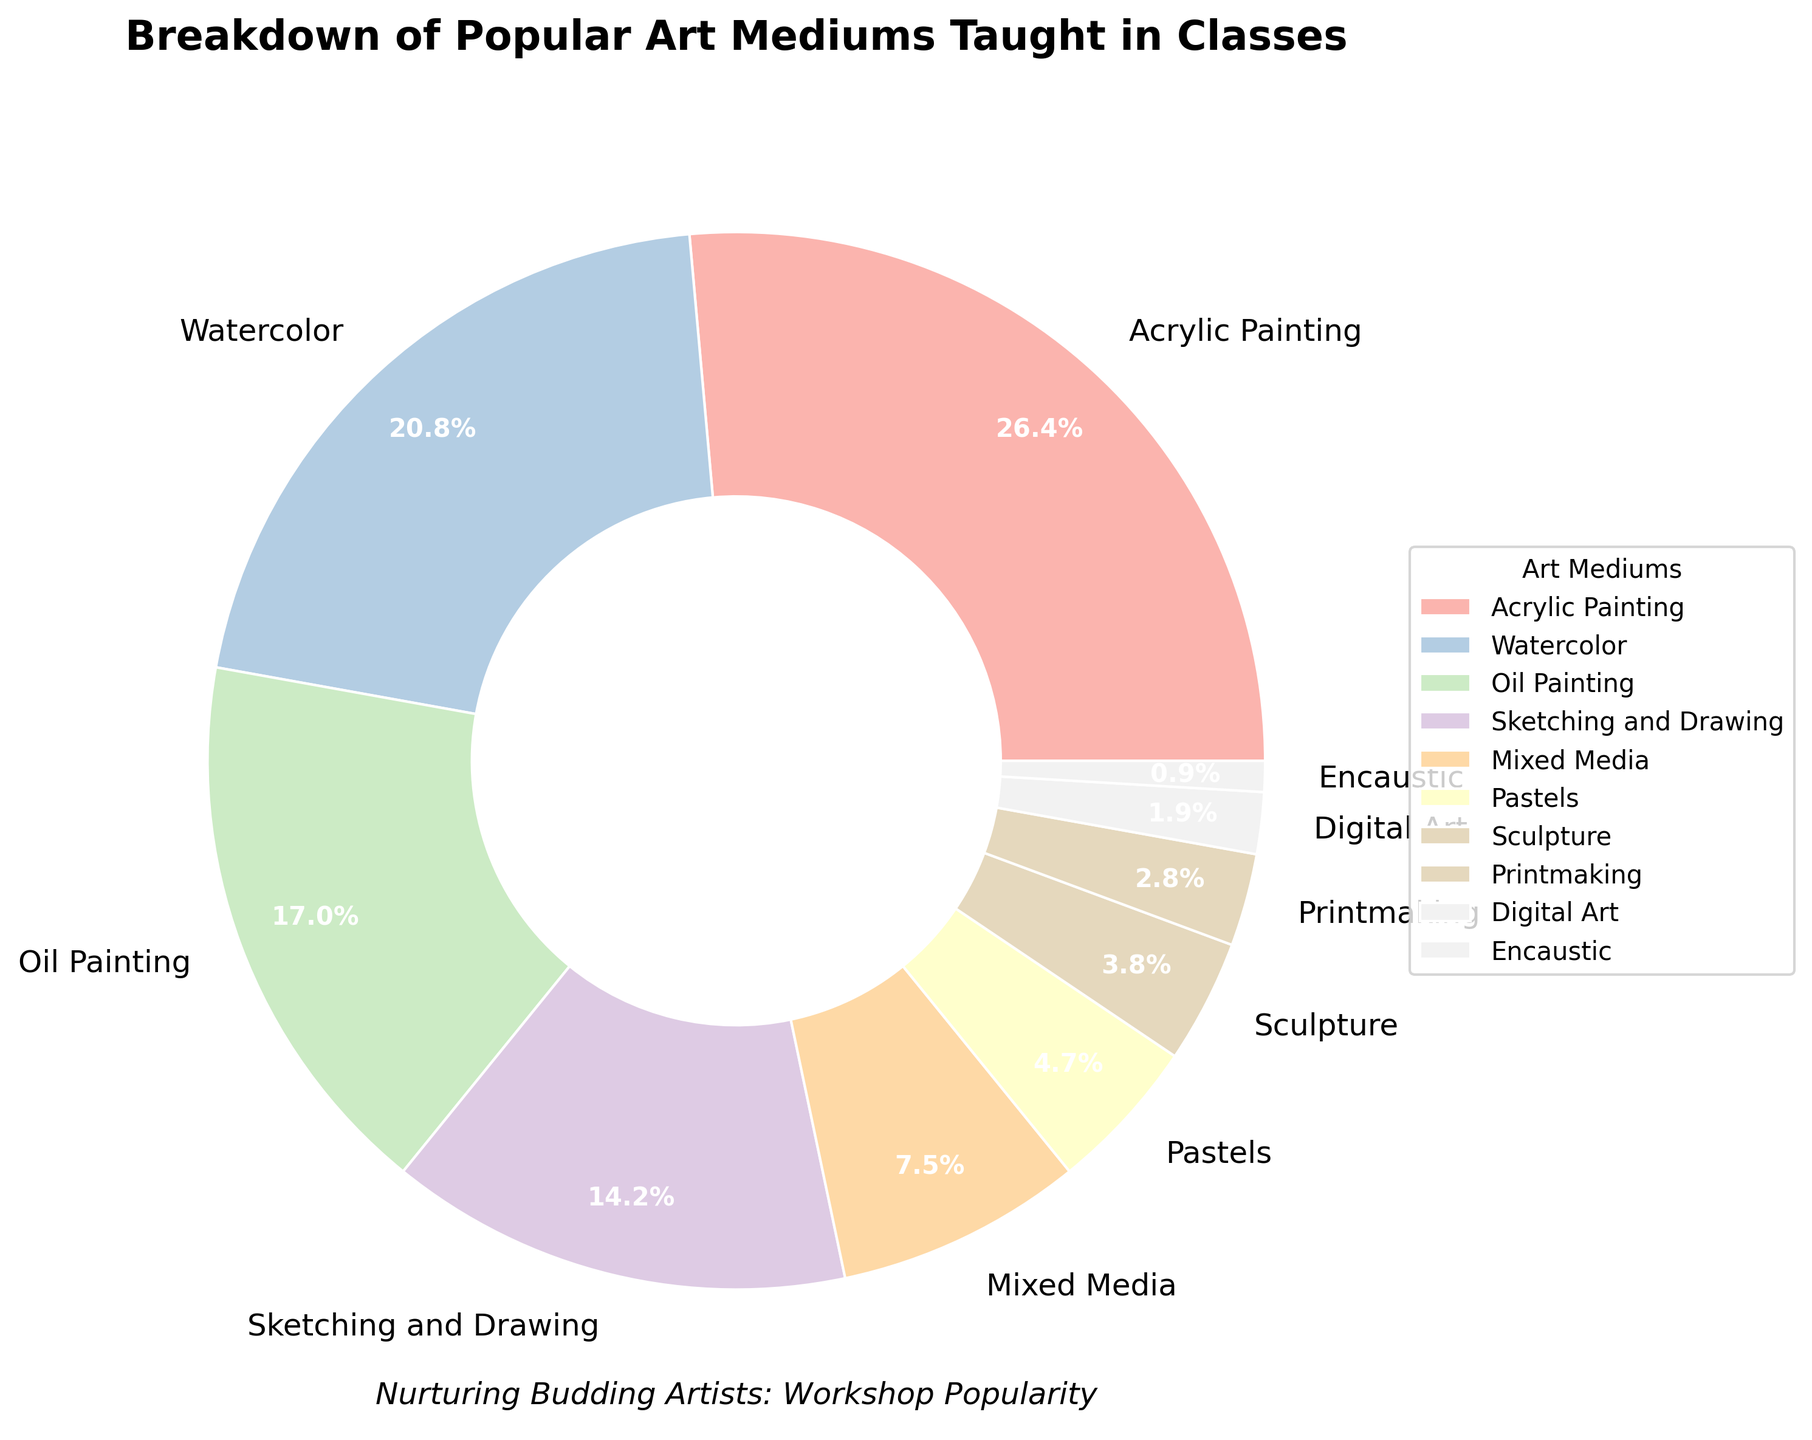What is the most popular art medium taught in classes? The slice with the largest percentage indicates the most popular art medium. According to the figure, Acrylic Painting occupies the largest section (28%).
Answer: Acrylic Painting Which two art mediums combined account for 40% of classes taught? Identify the art mediums and their corresponding percentages, then find two that add up to 40%. Watercolor (22%) and Sketching and Drawing (15%) together make 37%, so we need to add another. The correct combination is Oil Painting (18%) and Watercolor (22%), which together make 40%.
Answer: Oil Painting and Watercolor How many art mediums have a percentage higher than 10%? Count the number of slices that have a percentage value greater than 10%. Acrylic Painting (28%), Watercolor (22%), Oil Painting (18%), and Sketching and Drawing (15%) are all above 10%. There are 4 such mediums.
Answer: 4 Which art medium has the smallest percentage in the classes taught? Locate the smallest slice in the pie chart. The smallest slice corresponds to Encaustic, which has a percentage of 1%.
Answer: Encaustic Compare the combined percentage of Mixed Media, Pastels, and Sculpture with that of Sketching and Drawing. Which is higher? Calculate the total percentage of Mixed Media (8%), Pastels (5%), and Sculpture (4%) which is 8 + 5 + 4 = 17%. Sketching and Drawing has 15%. Therefore, 17% is higher than 15%.
Answer: Mixed Media, Pastels, and Sculpture What art medium constitutes just under a quarter of the total classes taught? A quarter or 25% is the reference. The medium closest to but less than 25% is Watercolor which is 22%.
Answer: Watercolor What is the total percentage of the top three most popular art mediums taught in classes? Identify the top three slices and add their percentages: Acrylic Painting (28%), Watercolor (22%), and Oil Painting (18%). So, 28 + 22 + 18 = 68%.
Answer: 68% Compare the percentage for Sketching and Drawing vs. Printmaking. Which is greater and by how much? Sketching and Drawing is 15% while Printmaking is 3%. The difference is 15 - 3 = 12%.
Answer: Sketching and Drawing by 12% Among Digital Art and Sculpture, which art medium is less popular and by how much? Digital Art has 2% and Sculpture has 4%. The difference is 4 - 2 = 2%. Digital Art is less popular by 2%.
Answer: Digital Art by 2% How many art mediums have a percentage less than 5%? Count the number of slices that have a percentage value less than 5%. Printmaking (3%), Digital Art (2%), and Encaustic (1%) all fit this category. There are 3 such mediums.
Answer: 3 